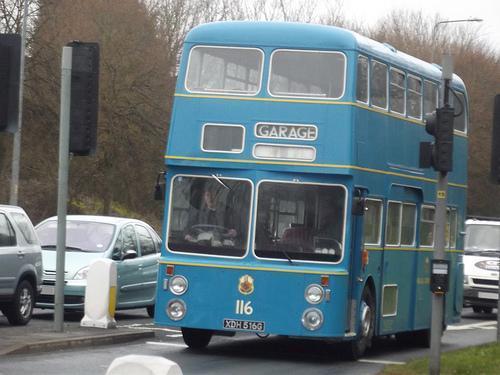How many buses are in the picture?
Give a very brief answer. 1. 